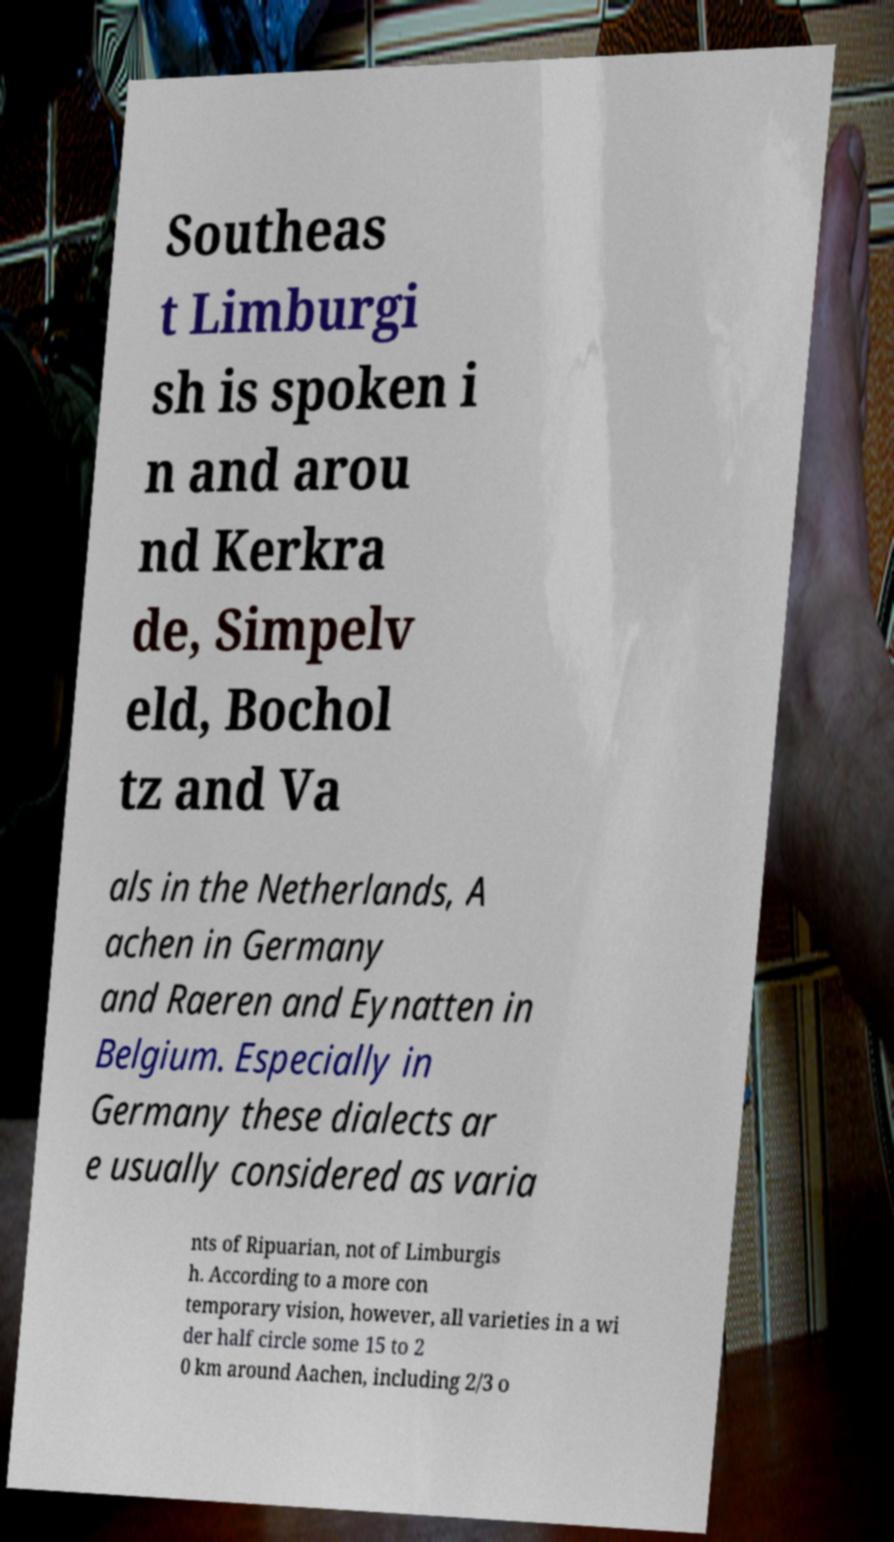Could you extract and type out the text from this image? Southeas t Limburgi sh is spoken i n and arou nd Kerkra de, Simpelv eld, Bochol tz and Va als in the Netherlands, A achen in Germany and Raeren and Eynatten in Belgium. Especially in Germany these dialects ar e usually considered as varia nts of Ripuarian, not of Limburgis h. According to a more con temporary vision, however, all varieties in a wi der half circle some 15 to 2 0 km around Aachen, including 2/3 o 